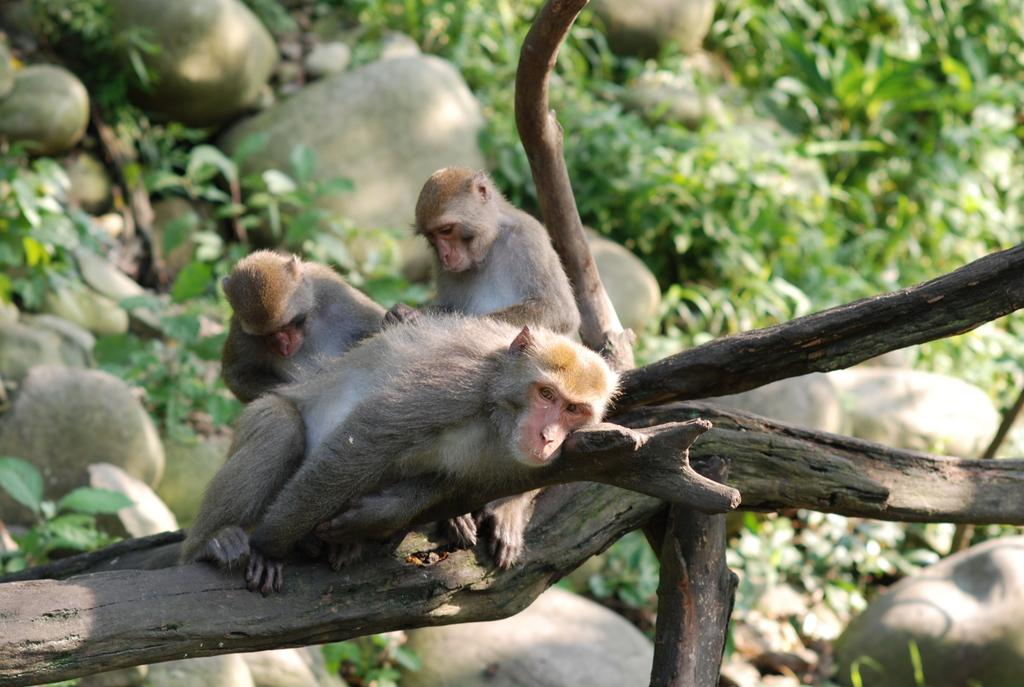What animals are on the wooden trunk in the image? There are monkeys on a wooden trunk in the image. What can be seen in the background of the image? There are rocks and plants in the background of the image. What type of minister is depicted in the image? There is no minister present in the image; it features monkeys on a wooden trunk and rocks and plants in the background. 